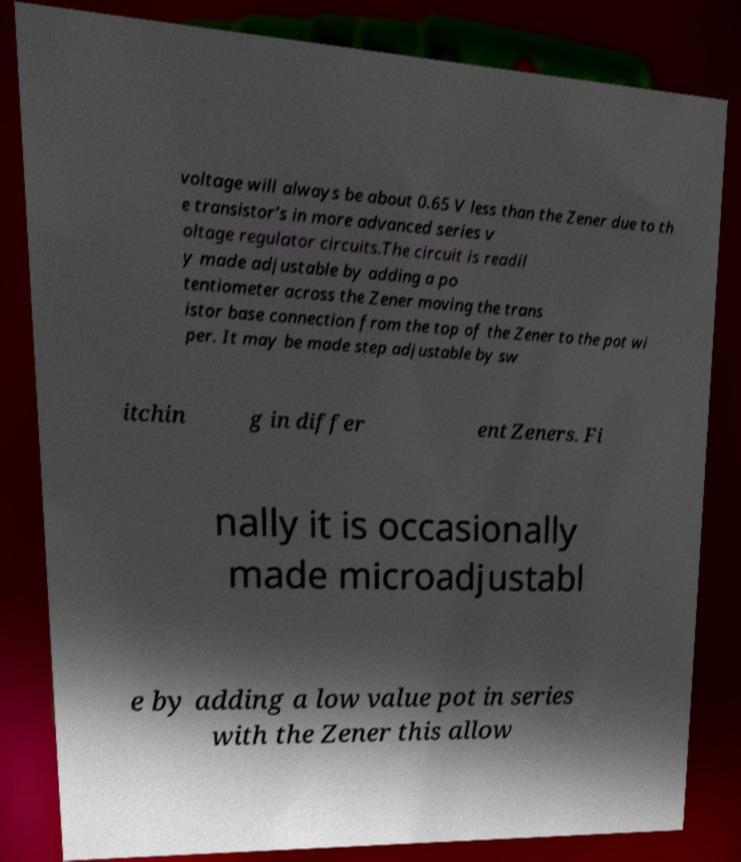Can you read and provide the text displayed in the image?This photo seems to have some interesting text. Can you extract and type it out for me? voltage will always be about 0.65 V less than the Zener due to th e transistor's in more advanced series v oltage regulator circuits.The circuit is readil y made adjustable by adding a po tentiometer across the Zener moving the trans istor base connection from the top of the Zener to the pot wi per. It may be made step adjustable by sw itchin g in differ ent Zeners. Fi nally it is occasionally made microadjustabl e by adding a low value pot in series with the Zener this allow 